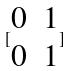Convert formula to latex. <formula><loc_0><loc_0><loc_500><loc_500>[ \begin{matrix} 0 & 1 \\ 0 & 1 \end{matrix} ]</formula> 